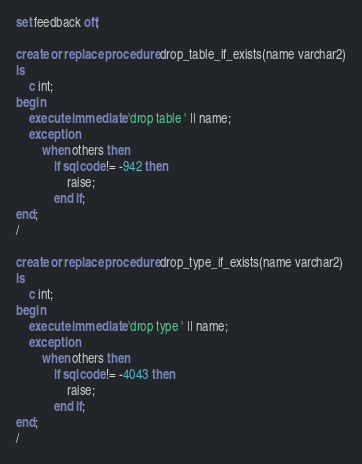<code> <loc_0><loc_0><loc_500><loc_500><_SQL_>set feedback off;

create or replace procedure drop_table_if_exists(name varchar2)
is 
    c int;
begin
    execute immediate 'drop table ' || name;
    exception
        when others then
            if sqlcode != -942 then
                raise;
            end if;
end;
/

create or replace procedure drop_type_if_exists(name varchar2)
is 
    c int;
begin
    execute immediate 'drop type ' || name;
    exception
        when others then
            if sqlcode != -4043 then
                raise;
            end if;
end;
/</code> 